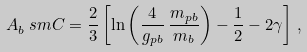<formula> <loc_0><loc_0><loc_500><loc_500>A _ { b } ^ { \ } s m C = \frac { 2 } { 3 } \left [ \ln \left ( \frac { 4 } { g _ { p b } } \, \frac { m _ { p b } } { m _ { b } } \right ) - \frac { 1 } { 2 } - 2 \gamma \right ] \, ,</formula> 